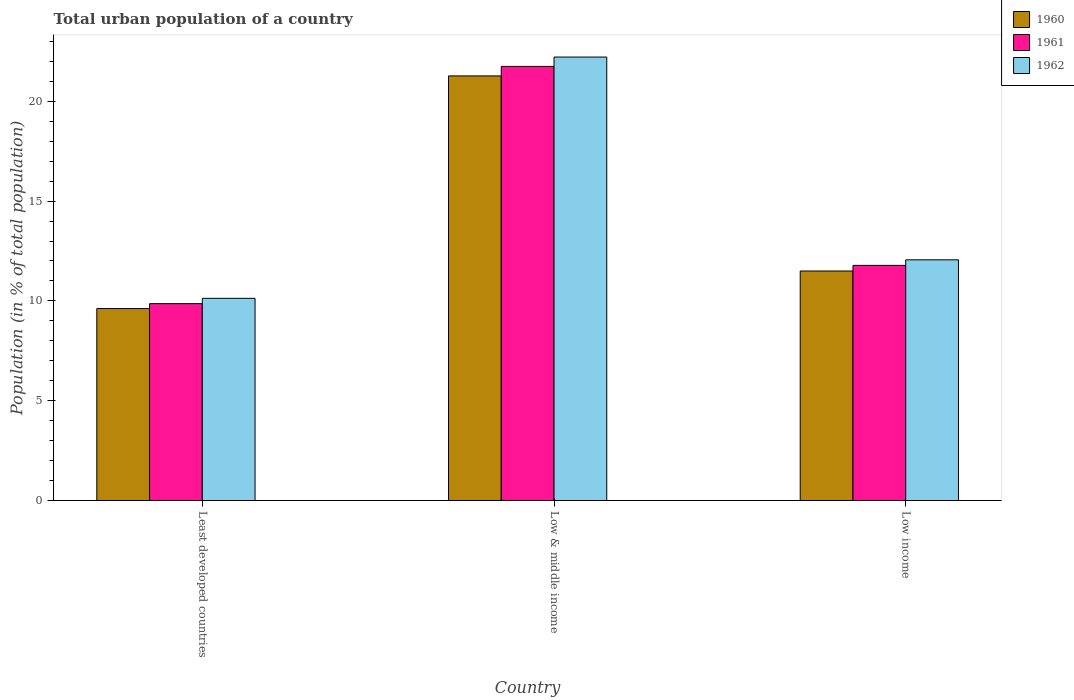How many different coloured bars are there?
Your answer should be very brief. 3. How many groups of bars are there?
Provide a short and direct response. 3. How many bars are there on the 1st tick from the left?
Offer a very short reply. 3. What is the label of the 1st group of bars from the left?
Provide a short and direct response. Least developed countries. What is the urban population in 1960 in Low income?
Give a very brief answer. 11.5. Across all countries, what is the maximum urban population in 1960?
Your answer should be compact. 21.27. Across all countries, what is the minimum urban population in 1960?
Make the answer very short. 9.62. In which country was the urban population in 1960 minimum?
Ensure brevity in your answer.  Least developed countries. What is the total urban population in 1962 in the graph?
Offer a terse response. 44.41. What is the difference between the urban population in 1960 in Least developed countries and that in Low & middle income?
Offer a terse response. -11.66. What is the difference between the urban population in 1962 in Least developed countries and the urban population in 1961 in Low & middle income?
Ensure brevity in your answer.  -11.62. What is the average urban population in 1962 per country?
Provide a short and direct response. 14.8. What is the difference between the urban population of/in 1961 and urban population of/in 1962 in Low income?
Give a very brief answer. -0.28. In how many countries, is the urban population in 1962 greater than 18 %?
Offer a very short reply. 1. What is the ratio of the urban population in 1960 in Least developed countries to that in Low income?
Offer a terse response. 0.84. Is the difference between the urban population in 1961 in Least developed countries and Low & middle income greater than the difference between the urban population in 1962 in Least developed countries and Low & middle income?
Ensure brevity in your answer.  Yes. What is the difference between the highest and the second highest urban population in 1961?
Keep it short and to the point. -1.92. What is the difference between the highest and the lowest urban population in 1960?
Ensure brevity in your answer.  11.66. Is the sum of the urban population in 1962 in Least developed countries and Low & middle income greater than the maximum urban population in 1961 across all countries?
Make the answer very short. Yes. What does the 1st bar from the left in Low income represents?
Provide a short and direct response. 1960. What does the 1st bar from the right in Low income represents?
Offer a very short reply. 1962. Is it the case that in every country, the sum of the urban population in 1960 and urban population in 1961 is greater than the urban population in 1962?
Offer a very short reply. Yes. Are all the bars in the graph horizontal?
Make the answer very short. No. How many countries are there in the graph?
Offer a terse response. 3. What is the difference between two consecutive major ticks on the Y-axis?
Provide a succinct answer. 5. Are the values on the major ticks of Y-axis written in scientific E-notation?
Make the answer very short. No. Does the graph contain grids?
Your response must be concise. No. How are the legend labels stacked?
Keep it short and to the point. Vertical. What is the title of the graph?
Your answer should be very brief. Total urban population of a country. Does "2015" appear as one of the legend labels in the graph?
Offer a very short reply. No. What is the label or title of the X-axis?
Your response must be concise. Country. What is the label or title of the Y-axis?
Make the answer very short. Population (in % of total population). What is the Population (in % of total population) in 1960 in Least developed countries?
Your response must be concise. 9.62. What is the Population (in % of total population) in 1961 in Least developed countries?
Provide a succinct answer. 9.86. What is the Population (in % of total population) of 1962 in Least developed countries?
Your answer should be very brief. 10.13. What is the Population (in % of total population) in 1960 in Low & middle income?
Give a very brief answer. 21.27. What is the Population (in % of total population) in 1961 in Low & middle income?
Offer a terse response. 21.75. What is the Population (in % of total population) of 1962 in Low & middle income?
Your response must be concise. 22.22. What is the Population (in % of total population) of 1960 in Low income?
Offer a terse response. 11.5. What is the Population (in % of total population) in 1961 in Low income?
Provide a short and direct response. 11.78. What is the Population (in % of total population) of 1962 in Low income?
Give a very brief answer. 12.06. Across all countries, what is the maximum Population (in % of total population) in 1960?
Your answer should be compact. 21.27. Across all countries, what is the maximum Population (in % of total population) of 1961?
Ensure brevity in your answer.  21.75. Across all countries, what is the maximum Population (in % of total population) of 1962?
Offer a very short reply. 22.22. Across all countries, what is the minimum Population (in % of total population) of 1960?
Offer a terse response. 9.62. Across all countries, what is the minimum Population (in % of total population) in 1961?
Provide a short and direct response. 9.86. Across all countries, what is the minimum Population (in % of total population) of 1962?
Provide a succinct answer. 10.13. What is the total Population (in % of total population) in 1960 in the graph?
Offer a terse response. 42.39. What is the total Population (in % of total population) in 1961 in the graph?
Your answer should be compact. 43.39. What is the total Population (in % of total population) in 1962 in the graph?
Provide a succinct answer. 44.41. What is the difference between the Population (in % of total population) of 1960 in Least developed countries and that in Low & middle income?
Ensure brevity in your answer.  -11.66. What is the difference between the Population (in % of total population) of 1961 in Least developed countries and that in Low & middle income?
Your answer should be very brief. -11.89. What is the difference between the Population (in % of total population) in 1962 in Least developed countries and that in Low & middle income?
Give a very brief answer. -12.09. What is the difference between the Population (in % of total population) in 1960 in Least developed countries and that in Low income?
Ensure brevity in your answer.  -1.88. What is the difference between the Population (in % of total population) in 1961 in Least developed countries and that in Low income?
Your response must be concise. -1.92. What is the difference between the Population (in % of total population) in 1962 in Least developed countries and that in Low income?
Provide a short and direct response. -1.93. What is the difference between the Population (in % of total population) in 1960 in Low & middle income and that in Low income?
Make the answer very short. 9.77. What is the difference between the Population (in % of total population) of 1961 in Low & middle income and that in Low income?
Offer a terse response. 9.97. What is the difference between the Population (in % of total population) in 1962 in Low & middle income and that in Low income?
Offer a very short reply. 10.16. What is the difference between the Population (in % of total population) of 1960 in Least developed countries and the Population (in % of total population) of 1961 in Low & middle income?
Your answer should be very brief. -12.13. What is the difference between the Population (in % of total population) of 1960 in Least developed countries and the Population (in % of total population) of 1962 in Low & middle income?
Keep it short and to the point. -12.6. What is the difference between the Population (in % of total population) of 1961 in Least developed countries and the Population (in % of total population) of 1962 in Low & middle income?
Your answer should be compact. -12.36. What is the difference between the Population (in % of total population) in 1960 in Least developed countries and the Population (in % of total population) in 1961 in Low income?
Your response must be concise. -2.16. What is the difference between the Population (in % of total population) in 1960 in Least developed countries and the Population (in % of total population) in 1962 in Low income?
Your answer should be compact. -2.44. What is the difference between the Population (in % of total population) in 1961 in Least developed countries and the Population (in % of total population) in 1962 in Low income?
Provide a succinct answer. -2.2. What is the difference between the Population (in % of total population) in 1960 in Low & middle income and the Population (in % of total population) in 1961 in Low income?
Offer a terse response. 9.49. What is the difference between the Population (in % of total population) in 1960 in Low & middle income and the Population (in % of total population) in 1962 in Low income?
Provide a short and direct response. 9.21. What is the difference between the Population (in % of total population) of 1961 in Low & middle income and the Population (in % of total population) of 1962 in Low income?
Provide a succinct answer. 9.69. What is the average Population (in % of total population) of 1960 per country?
Your response must be concise. 14.13. What is the average Population (in % of total population) in 1961 per country?
Keep it short and to the point. 14.46. What is the average Population (in % of total population) of 1962 per country?
Give a very brief answer. 14.8. What is the difference between the Population (in % of total population) in 1960 and Population (in % of total population) in 1961 in Least developed countries?
Keep it short and to the point. -0.25. What is the difference between the Population (in % of total population) in 1960 and Population (in % of total population) in 1962 in Least developed countries?
Your response must be concise. -0.51. What is the difference between the Population (in % of total population) of 1961 and Population (in % of total population) of 1962 in Least developed countries?
Provide a succinct answer. -0.27. What is the difference between the Population (in % of total population) of 1960 and Population (in % of total population) of 1961 in Low & middle income?
Your answer should be compact. -0.48. What is the difference between the Population (in % of total population) of 1960 and Population (in % of total population) of 1962 in Low & middle income?
Make the answer very short. -0.95. What is the difference between the Population (in % of total population) in 1961 and Population (in % of total population) in 1962 in Low & middle income?
Provide a succinct answer. -0.47. What is the difference between the Population (in % of total population) of 1960 and Population (in % of total population) of 1961 in Low income?
Your answer should be very brief. -0.28. What is the difference between the Population (in % of total population) of 1960 and Population (in % of total population) of 1962 in Low income?
Offer a very short reply. -0.56. What is the difference between the Population (in % of total population) in 1961 and Population (in % of total population) in 1962 in Low income?
Provide a succinct answer. -0.28. What is the ratio of the Population (in % of total population) in 1960 in Least developed countries to that in Low & middle income?
Offer a terse response. 0.45. What is the ratio of the Population (in % of total population) of 1961 in Least developed countries to that in Low & middle income?
Make the answer very short. 0.45. What is the ratio of the Population (in % of total population) of 1962 in Least developed countries to that in Low & middle income?
Ensure brevity in your answer.  0.46. What is the ratio of the Population (in % of total population) of 1960 in Least developed countries to that in Low income?
Ensure brevity in your answer.  0.84. What is the ratio of the Population (in % of total population) of 1961 in Least developed countries to that in Low income?
Offer a very short reply. 0.84. What is the ratio of the Population (in % of total population) of 1962 in Least developed countries to that in Low income?
Offer a terse response. 0.84. What is the ratio of the Population (in % of total population) in 1960 in Low & middle income to that in Low income?
Provide a short and direct response. 1.85. What is the ratio of the Population (in % of total population) in 1961 in Low & middle income to that in Low income?
Your answer should be compact. 1.85. What is the ratio of the Population (in % of total population) of 1962 in Low & middle income to that in Low income?
Your answer should be very brief. 1.84. What is the difference between the highest and the second highest Population (in % of total population) of 1960?
Offer a terse response. 9.77. What is the difference between the highest and the second highest Population (in % of total population) of 1961?
Your answer should be compact. 9.97. What is the difference between the highest and the second highest Population (in % of total population) in 1962?
Make the answer very short. 10.16. What is the difference between the highest and the lowest Population (in % of total population) in 1960?
Keep it short and to the point. 11.66. What is the difference between the highest and the lowest Population (in % of total population) in 1961?
Give a very brief answer. 11.89. What is the difference between the highest and the lowest Population (in % of total population) of 1962?
Keep it short and to the point. 12.09. 